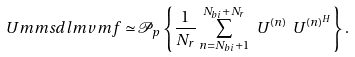Convert formula to latex. <formula><loc_0><loc_0><loc_500><loc_500>\ U m m s d l m v m f \simeq \mathcal { P } _ { p } \left \{ \frac { 1 } { N _ { r } } \sum _ { n = N _ { b i } + 1 } ^ { N _ { b i } + N _ { r } } \ U ^ { ( n ) } \ U ^ { ( n ) ^ { H } } \right \} .</formula> 